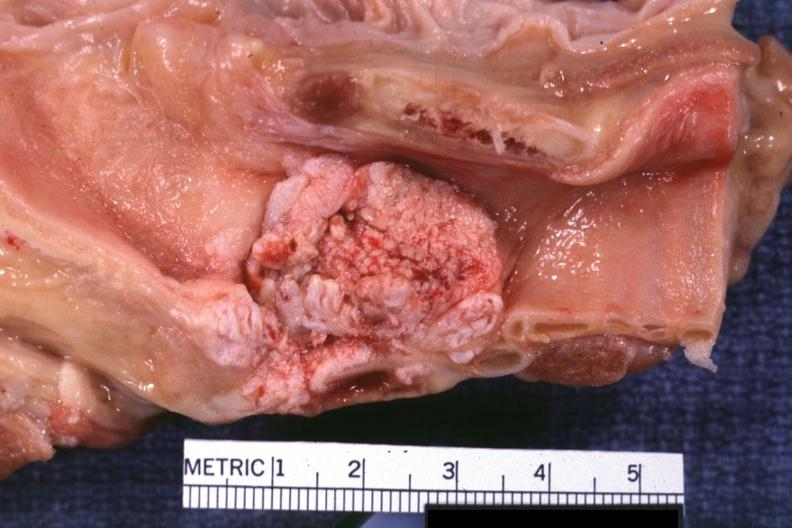what does this image show?
Answer the question using a single word or phrase. Large fungating lesion very good photo 